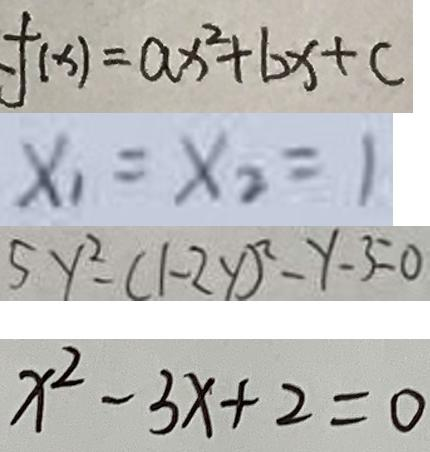<formula> <loc_0><loc_0><loc_500><loc_500>f ( x ) = a x ^ { 2 } + b x + c 
 x _ { 1 } = x _ { 2 } = 1 
 5 y ^ { 2 } - ( 1 - 2 y ) ^ { 2 } - y - 3 = 0 
 x ^ { 2 } - 3 x + 2 = 0</formula> 